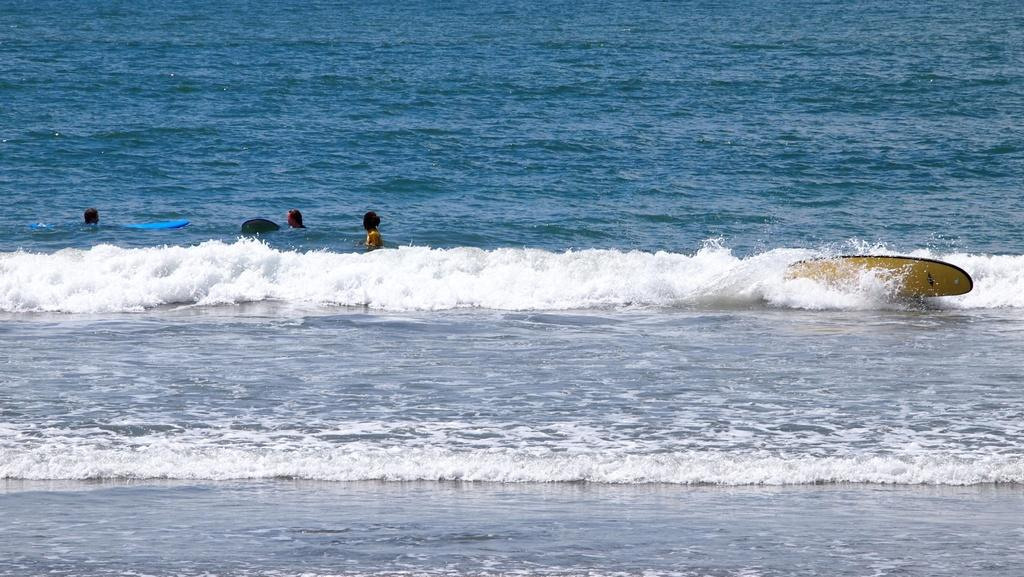What are the people in the image doing? The people in the image are in the water. What object can be seen on the water? There is a surfing board on the water. How many boys are answering the questions in the image? There are no boys or questions present in the image. What is the rate of the water in the image? The rate of the water cannot be determined from the image, as it does not provide information about the water's speed or flow. 